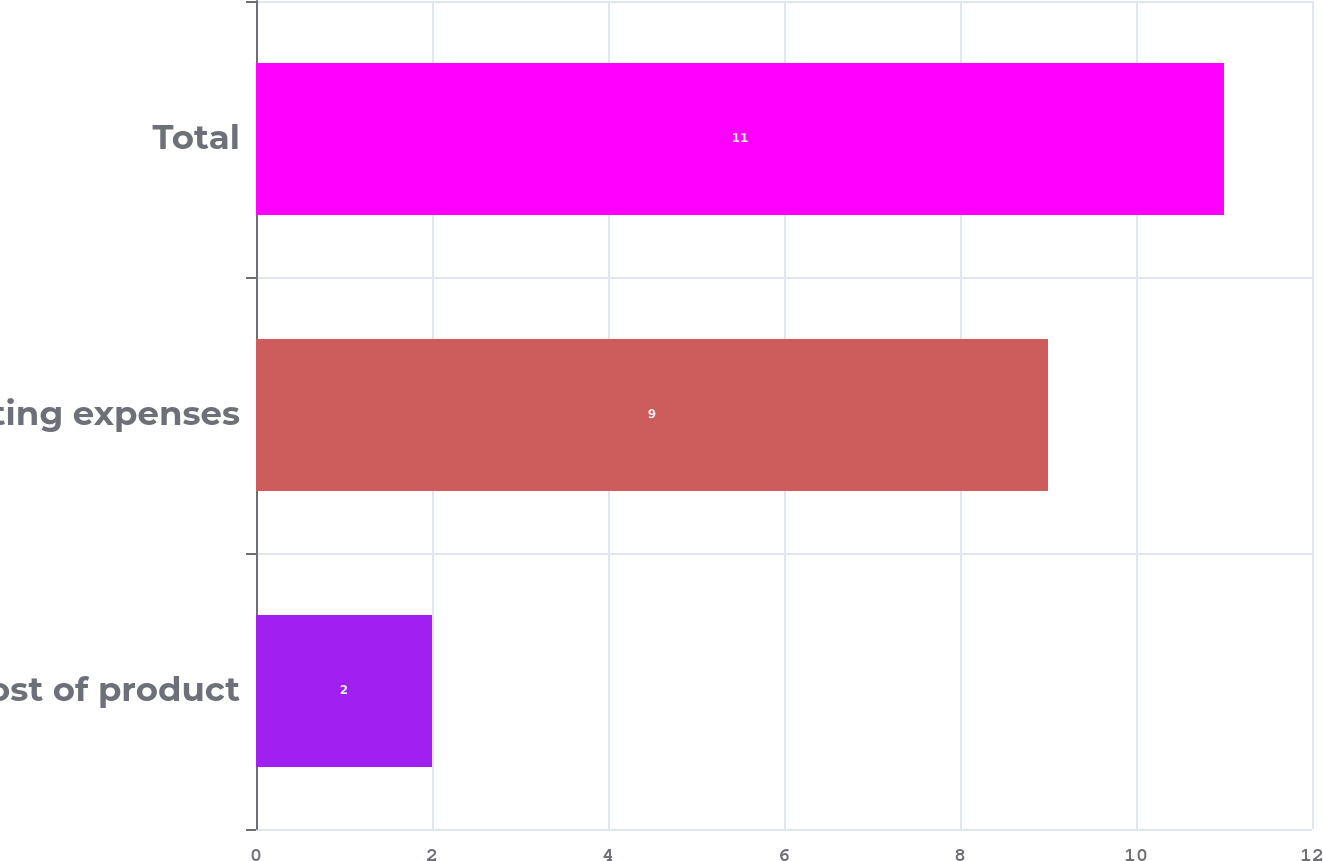Convert chart. <chart><loc_0><loc_0><loc_500><loc_500><bar_chart><fcel>Cost of product<fcel>Operating expenses<fcel>Total<nl><fcel>2<fcel>9<fcel>11<nl></chart> 